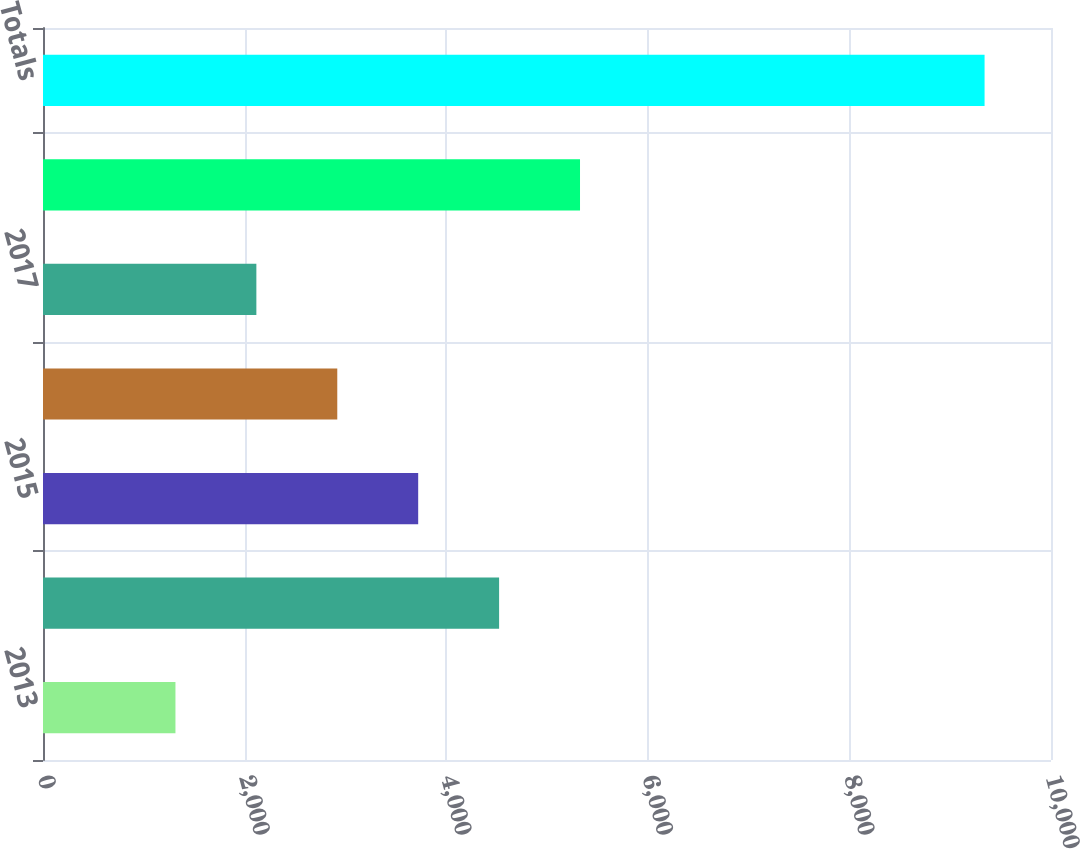Convert chart. <chart><loc_0><loc_0><loc_500><loc_500><bar_chart><fcel>2013<fcel>2014<fcel>2015<fcel>2016<fcel>2017<fcel>Thereafter<fcel>Totals<nl><fcel>1314<fcel>4524.8<fcel>3722.1<fcel>2919.4<fcel>2116.7<fcel>5327.5<fcel>9341<nl></chart> 